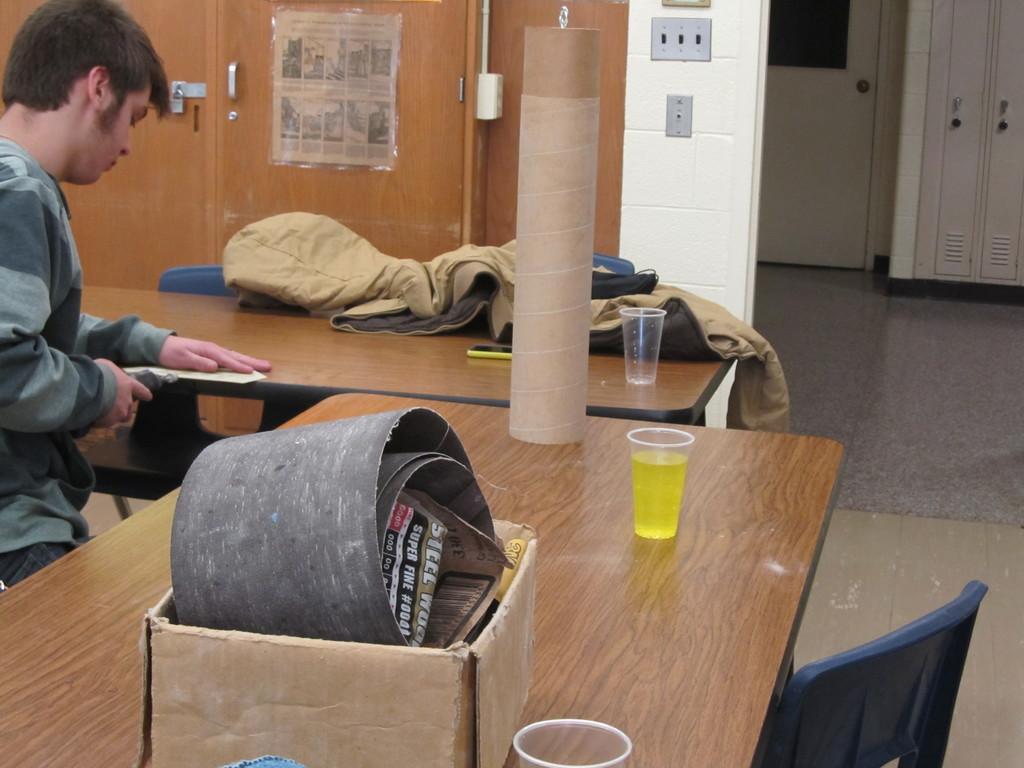Describe this image in one or two sentences. In this image there is a person at the left side of the image wearing ash color T-shirt and at the middle of the image there is a glass and cardboard box on top of the table. 